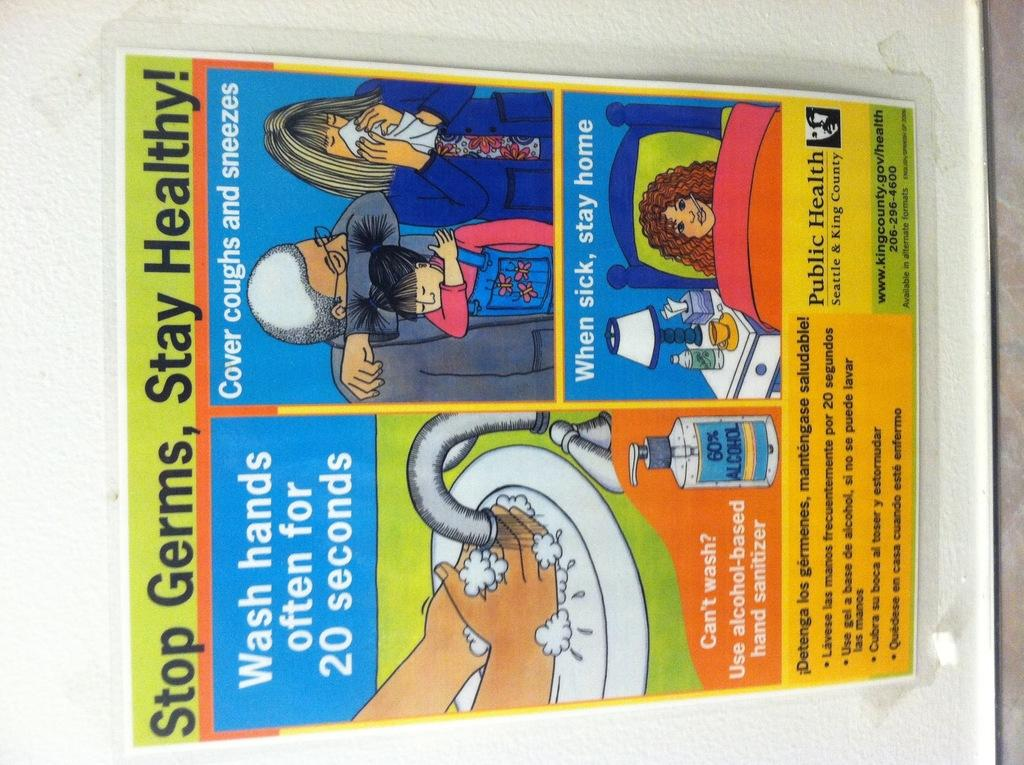What is located in the foreground of the image? There is a poster in the foreground of the image. Where is the poster placed? The poster is on a wall. What is the main topic of the poster? The poster is about maintaining hygiene. Can you see a ball bouncing in the stream in the image? There is no ball or stream present in the image; it features a poster on a wall about maintaining hygiene. 